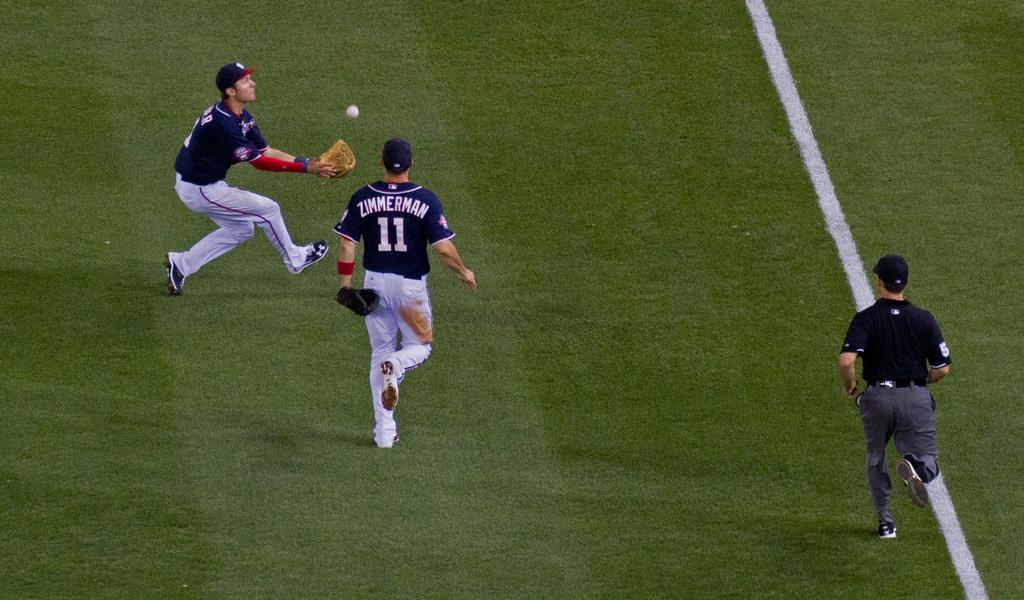What number is zimmerman?
Your answer should be compact. 11. 